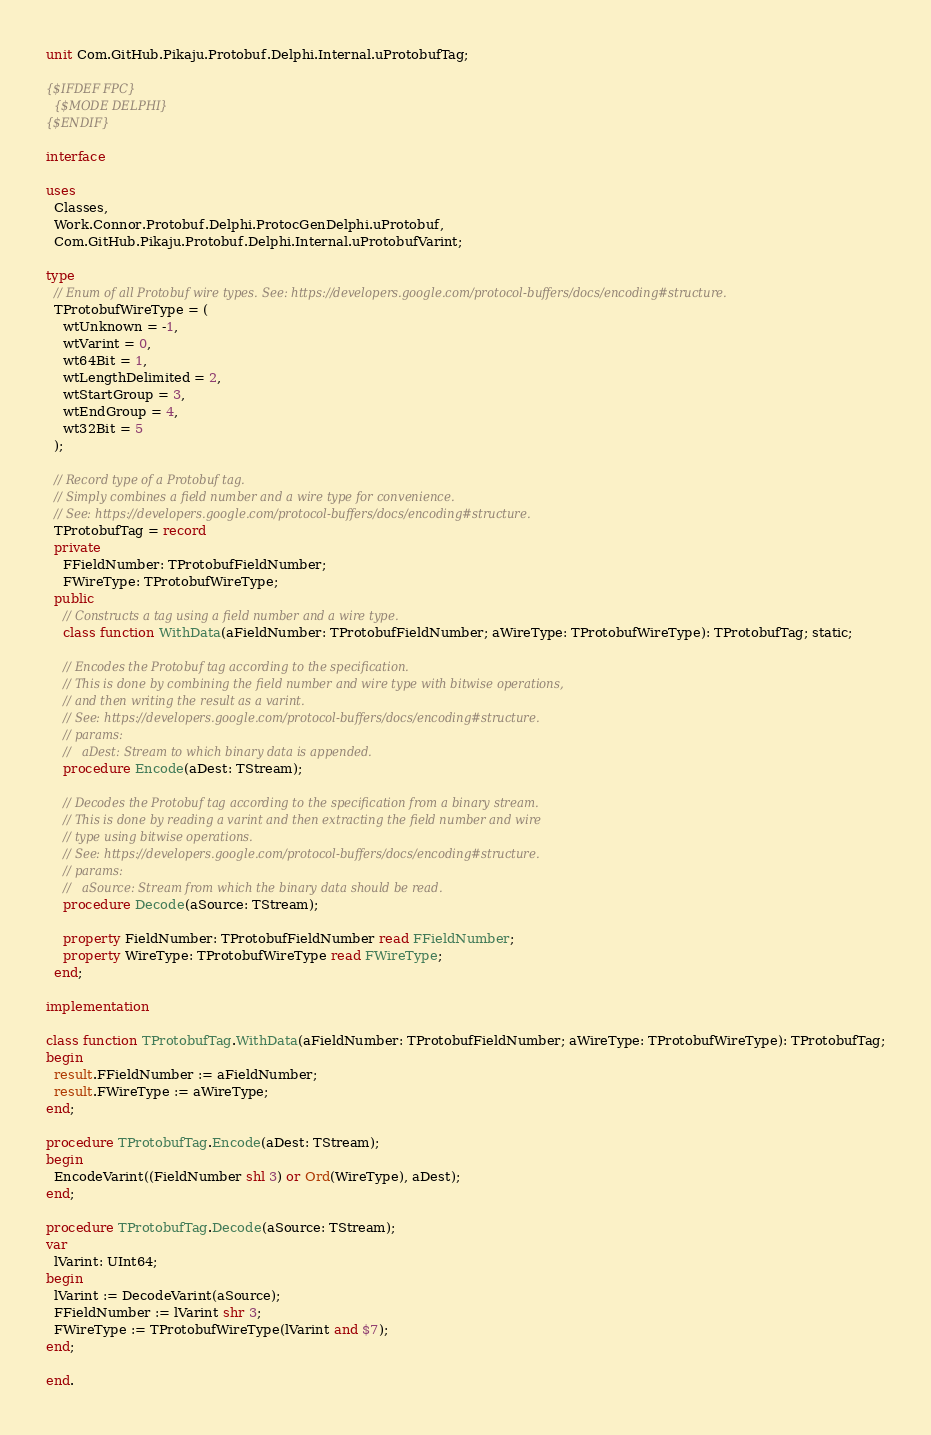<code> <loc_0><loc_0><loc_500><loc_500><_Pascal_>unit Com.GitHub.Pikaju.Protobuf.Delphi.Internal.uProtobufTag;

{$IFDEF FPC}
  {$MODE DELPHI}
{$ENDIF}

interface

uses
  Classes,
  Work.Connor.Protobuf.Delphi.ProtocGenDelphi.uProtobuf,
  Com.GitHub.Pikaju.Protobuf.Delphi.Internal.uProtobufVarint;

type
  // Enum of all Protobuf wire types. See: https://developers.google.com/protocol-buffers/docs/encoding#structure.
  TProtobufWireType = (
    wtUnknown = -1,
    wtVarint = 0,
    wt64Bit = 1,
    wtLengthDelimited = 2,
    wtStartGroup = 3,
    wtEndGroup = 4,
    wt32Bit = 5
  );

  // Record type of a Protobuf tag.
  // Simply combines a field number and a wire type for convenience.
  // See: https://developers.google.com/protocol-buffers/docs/encoding#structure.
  TProtobufTag = record
  private
    FFieldNumber: TProtobufFieldNumber;
    FWireType: TProtobufWireType;
  public
    // Constructs a tag using a field number and a wire type.
    class function WithData(aFieldNumber: TProtobufFieldNumber; aWireType: TProtobufWireType): TProtobufTag; static;

    // Encodes the Protobuf tag according to the specification.
    // This is done by combining the field number and wire type with bitwise operations,
    // and then writing the result as a varint.
    // See: https://developers.google.com/protocol-buffers/docs/encoding#structure.
    // params:
    //   aDest: Stream to which binary data is appended.
    procedure Encode(aDest: TStream);

    // Decodes the Protobuf tag according to the specification from a binary stream.
    // This is done by reading a varint and then extracting the field number and wire
    // type using bitwise operations.
    // See: https://developers.google.com/protocol-buffers/docs/encoding#structure.
    // params:
    //   aSource: Stream from which the binary data should be read.
    procedure Decode(aSource: TStream);

    property FieldNumber: TProtobufFieldNumber read FFieldNumber;
    property WireType: TProtobufWireType read FWireType;
  end;

implementation

class function TProtobufTag.WithData(aFieldNumber: TProtobufFieldNumber; aWireType: TProtobufWireType): TProtobufTag;
begin
  result.FFieldNumber := aFieldNumber;
  result.FWireType := aWireType;
end;

procedure TProtobufTag.Encode(aDest: TStream);
begin
  EncodeVarint((FieldNumber shl 3) or Ord(WireType), aDest);
end;

procedure TProtobufTag.Decode(aSource: TStream);
var
  lVarint: UInt64;
begin
  lVarint := DecodeVarint(aSource);
  FFieldNumber := lVarint shr 3;
  FWireType := TProtobufWireType(lVarint and $7);
end;

end.

</code> 